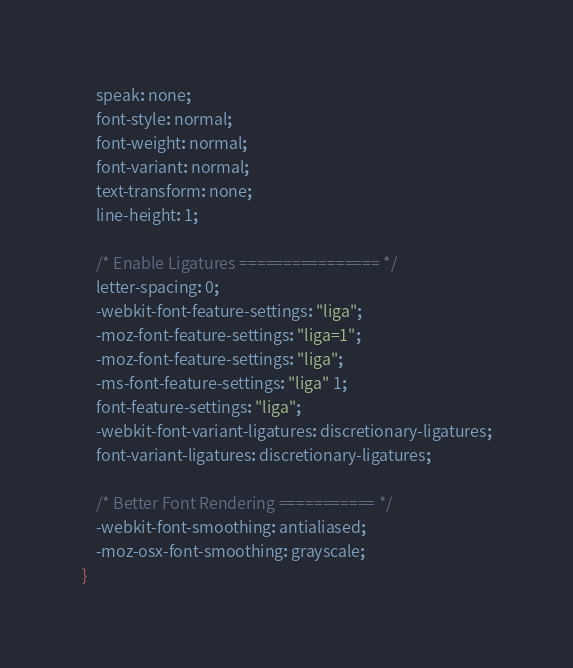<code> <loc_0><loc_0><loc_500><loc_500><_CSS_>    speak: none;
    font-style: normal;
    font-weight: normal;
    font-variant: normal;
    text-transform: none;
    line-height: 1;

    /* Enable Ligatures ================ */
    letter-spacing: 0;
    -webkit-font-feature-settings: "liga";
    -moz-font-feature-settings: "liga=1";
    -moz-font-feature-settings: "liga";
    -ms-font-feature-settings: "liga" 1;
    font-feature-settings: "liga";
    -webkit-font-variant-ligatures: discretionary-ligatures;
    font-variant-ligatures: discretionary-ligatures;

    /* Better Font Rendering =========== */
    -webkit-font-smoothing: antialiased;
    -moz-osx-font-smoothing: grayscale;
}
</code> 